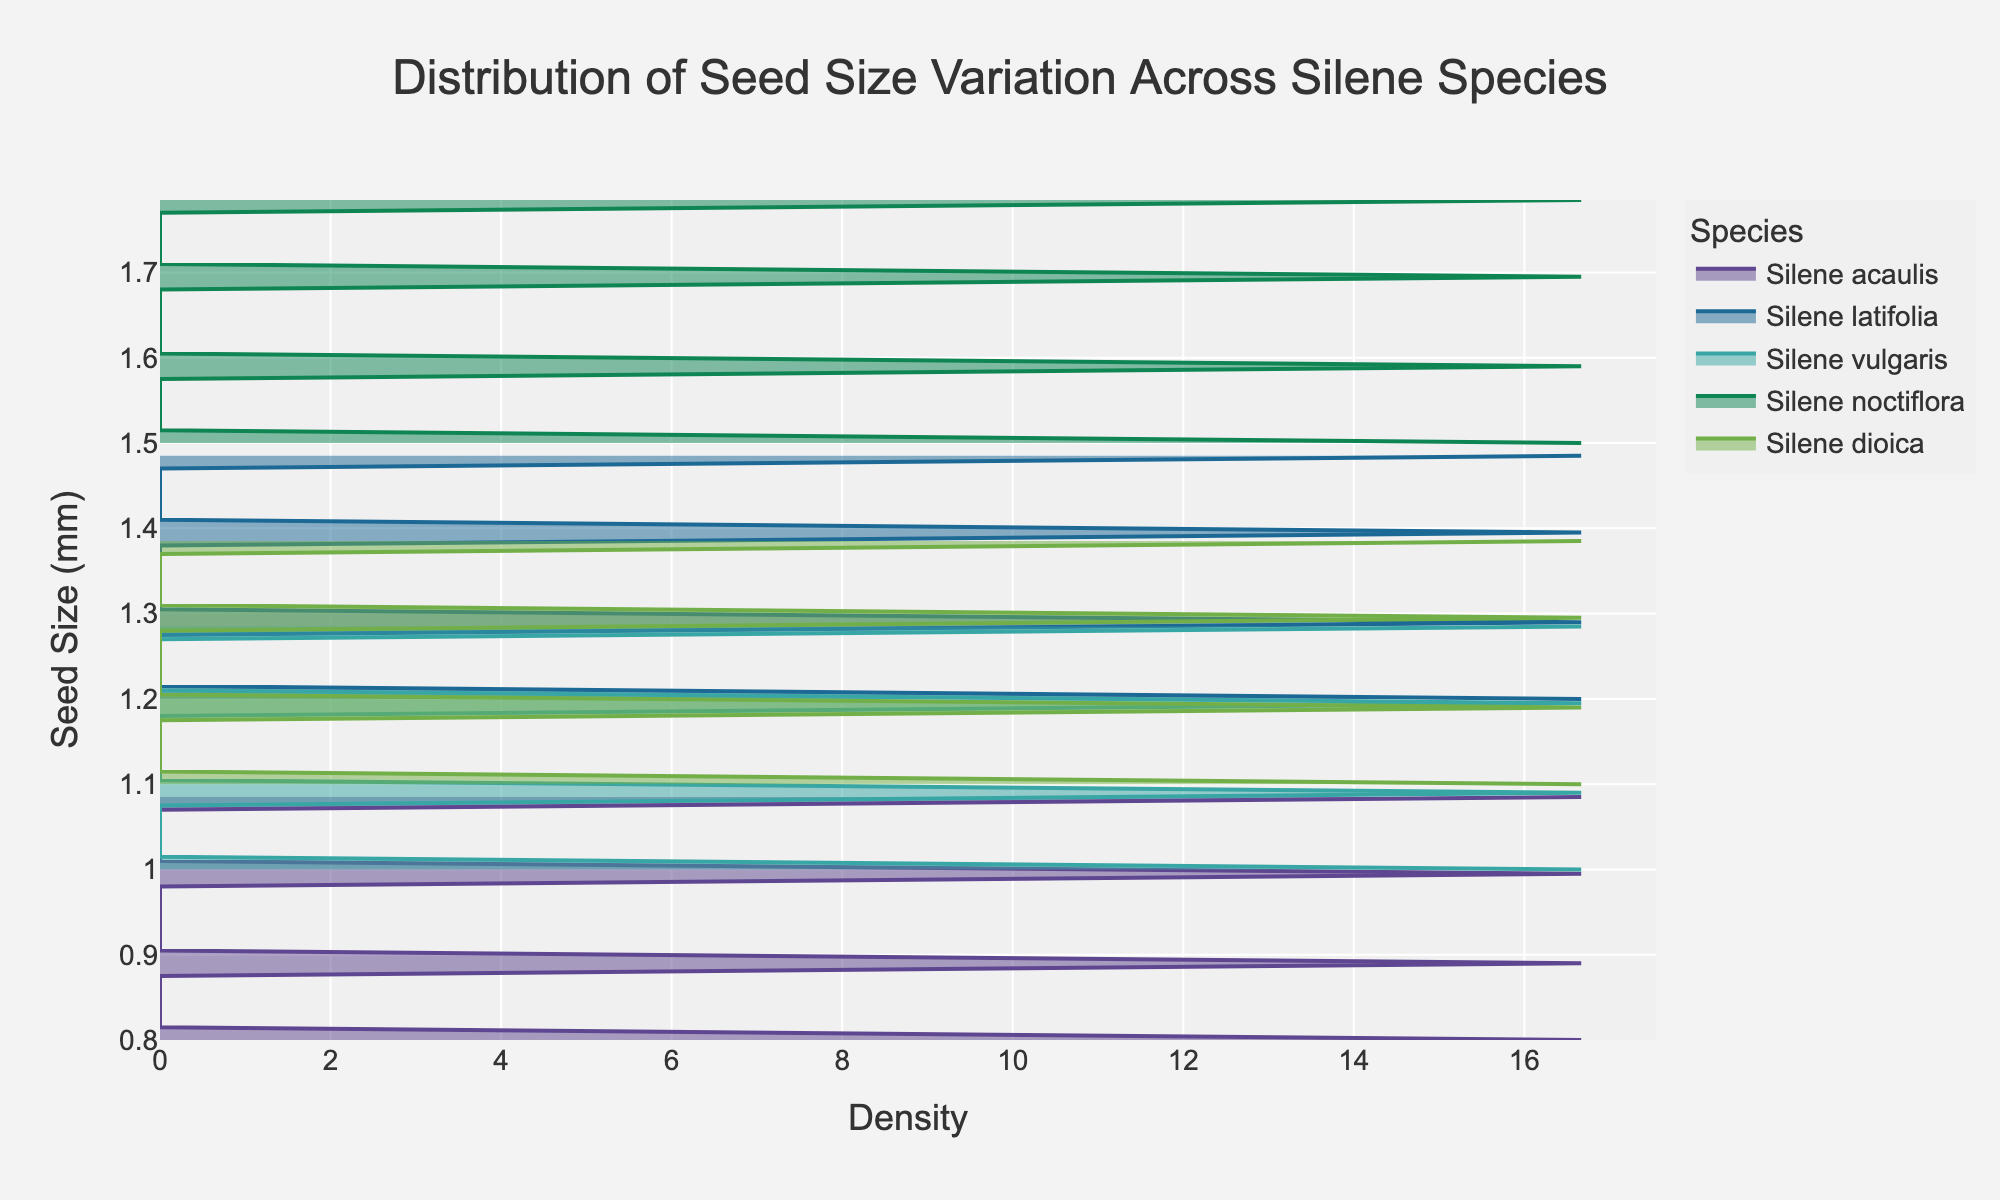What is the title of the figure? The title is usually displayed at the top of a figure and is generally the largest text in the plot layout.
Answer: Distribution of Seed Size Variation Across Silene Species What is the label for the x-axis? The label for the x-axis can be found along the horizontal axis, describing what the x-axis represents.
Answer: Density Which species has the widest distribution of seed sizes? By examining the range of seed sizes along the y-axis for each species, we can determine which species has the widest spread.
Answer: Silene noctiflora What is the seed size range for Silene acaulis? The y-axis shows seed sizes, and for Silene acaulis, we look at where its density plot extends between.
Answer: 0.8 mm to 1.1 mm Which species has the highest density peak? The density peak is the highest point along the x-axis for a given species. We look for the species with the maximum x-value in its density plot.
Answer: Silene noctiflora What is the average seed size for Silene vulgaris? To find the average, we need to look at the center of the density distribution for Silene vulgaris along the y-axis. It's usually around the middle of the seed size range depicted in the figure.
Answer: 1.15 mm Between Silene dioica and Silene latifolia, which has a higher maximum seed size? Compare the maximum y-values of the distributions for both species.
Answer: Silene latifolia Which species has a more uniform distribution of seed sizes? A uniform distribution will have a density plot that is more evenly spread out without sharp peaks.
Answer: Silene dioica How many species are shown in the figure? The number of distinct density plots corresponds to the number of different species in the dataset.
Answer: 5 Looking at the density plot, which species has seed sizes primarily between 1.5 mm and 1.8 mm? Identify the species with significant density values within the 1.5 mm to 1.8 mm range on the y-axis.
Answer: Silene noctiflora 